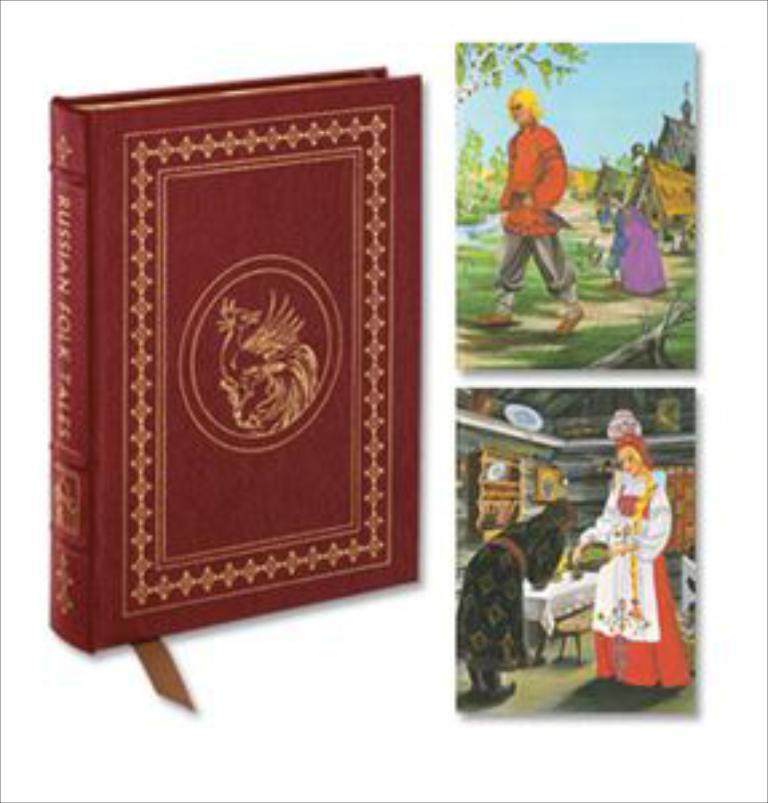Can you describe this image briefly? In this image we can see the picture of a book. We can also see some people, grass, trees, buildings and the sky. 